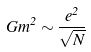<formula> <loc_0><loc_0><loc_500><loc_500>G m ^ { 2 } \sim \frac { e ^ { 2 } } { \sqrt { N } }</formula> 